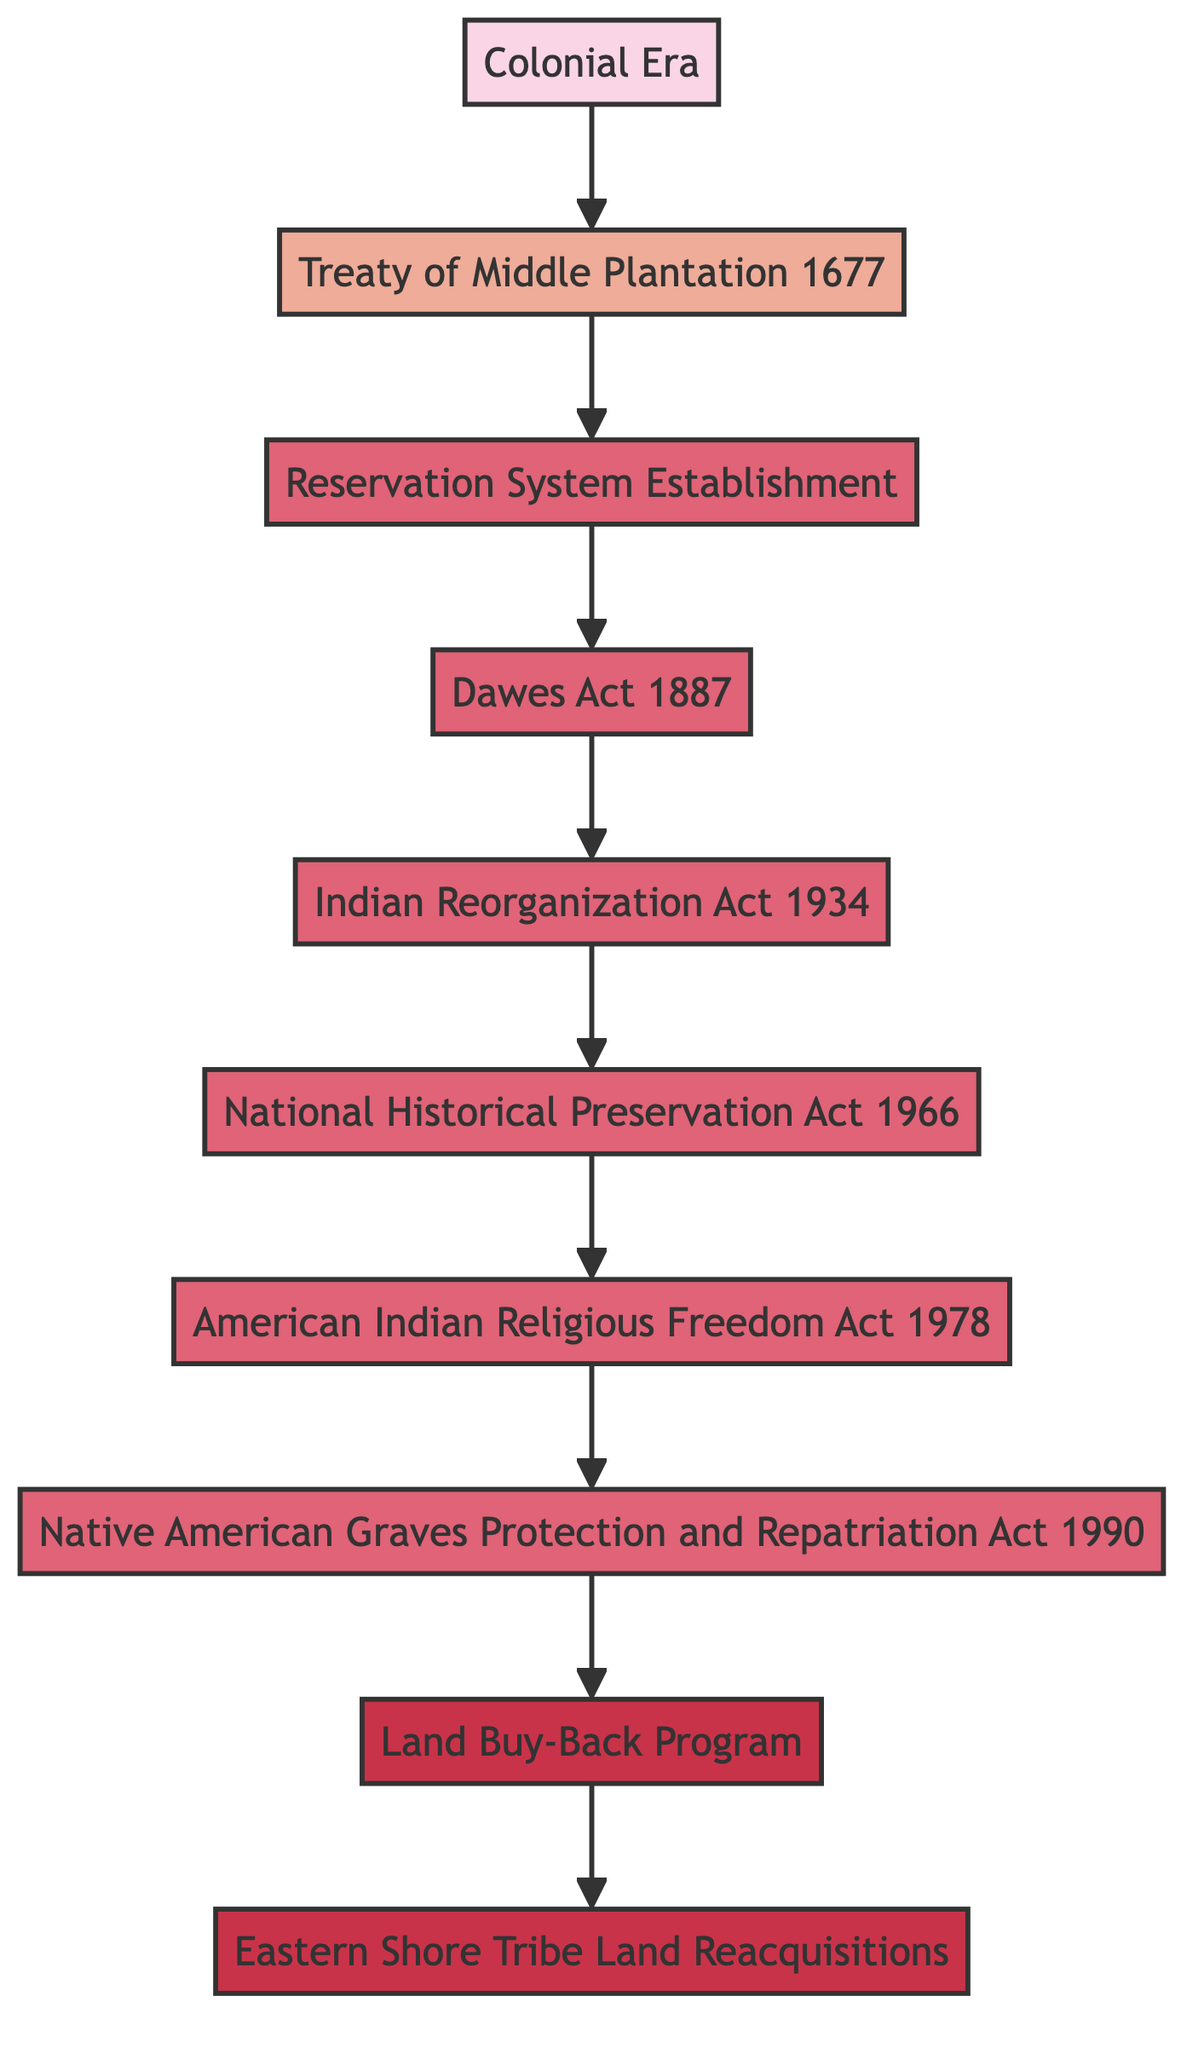What is the first event in the flow chart? The first event listed in the flow chart is "Colonial Era," which lays the foundation for the evolution of Indigenous land rights legislation.
Answer: Colonial Era How many acts are represented in the flow chart? There are five acts listed in the flow chart: Dawes Act, Indian Reorganization Act, National Historical Preservation Act, American Indian Religious Freedom Act, and Native American Graves Protection and Repatriation Act.
Answer: 5 What follows the Treaty of Middle Plantation (1677)? The node directly following the Treaty of Middle Plantation (1677) is the Reservation System Establishment, indicating the progression of legislation and policies regarding Indigenous land rights.
Answer: Reservation System Establishment Which program is associated with the Cobell Settlement? The program associated with the Cobell Settlement is the Land Buy-Back Program, which aims to restore fractionated land interests to tribal ownership.
Answer: Land Buy-Back Program Which act aimed to reverse the Dawes Act policies? The act that aimed to reverse the Dawes Act policies is the Indian Reorganization Act (1934), showing a shift towards recognizing Indigenous self-governance.
Answer: Indian Reorganization Act (1934) What is the final node in the flow chart? The final node in the flow chart is "Eastern Shore Tribe Land Reacquisitions," representing ongoing efforts by Eastern Shore tribes to reclaim ancestral lands.
Answer: Eastern Shore Tribe Land Reacquisitions What type of legislation is the National Historical Preservation Act (1966)? The National Historical Preservation Act (1966) is classified as an act, as indicated in the flow chart's structure and classification.
Answer: Act Explain the progression from the Colonial Era to the Land Buy-Back Program. The flow chart outlines a progression starting from the Colonial Era, which marked the beginning of land loss for Indigenous peoples. This is followed by the Treaty of Middle Plantation (1677) which aimed to protect some land rights. Next, the Reservation System was established, creating boundaries that limited land use. The Dawes Act (1887) aimed to individualize land ownership, followed by the Indian Reorganization Act (1934) which sought to restore some self-governance. This led to preservation efforts in the National Historical Preservation Act (1966) and protections established by the American Indian Religious Freedom Act (1978) and the Native American Graves Protection and Repatriation Act (1990). Finally, the Land Buy-Back Program initiates modern efforts to reclaim lands, completing the evolution of Indigenous land rights legislation.
Answer: The evolution spans from the Colonial Era to the Land Buy-Back Program, signifying centuries of legislation and reclamation efforts 